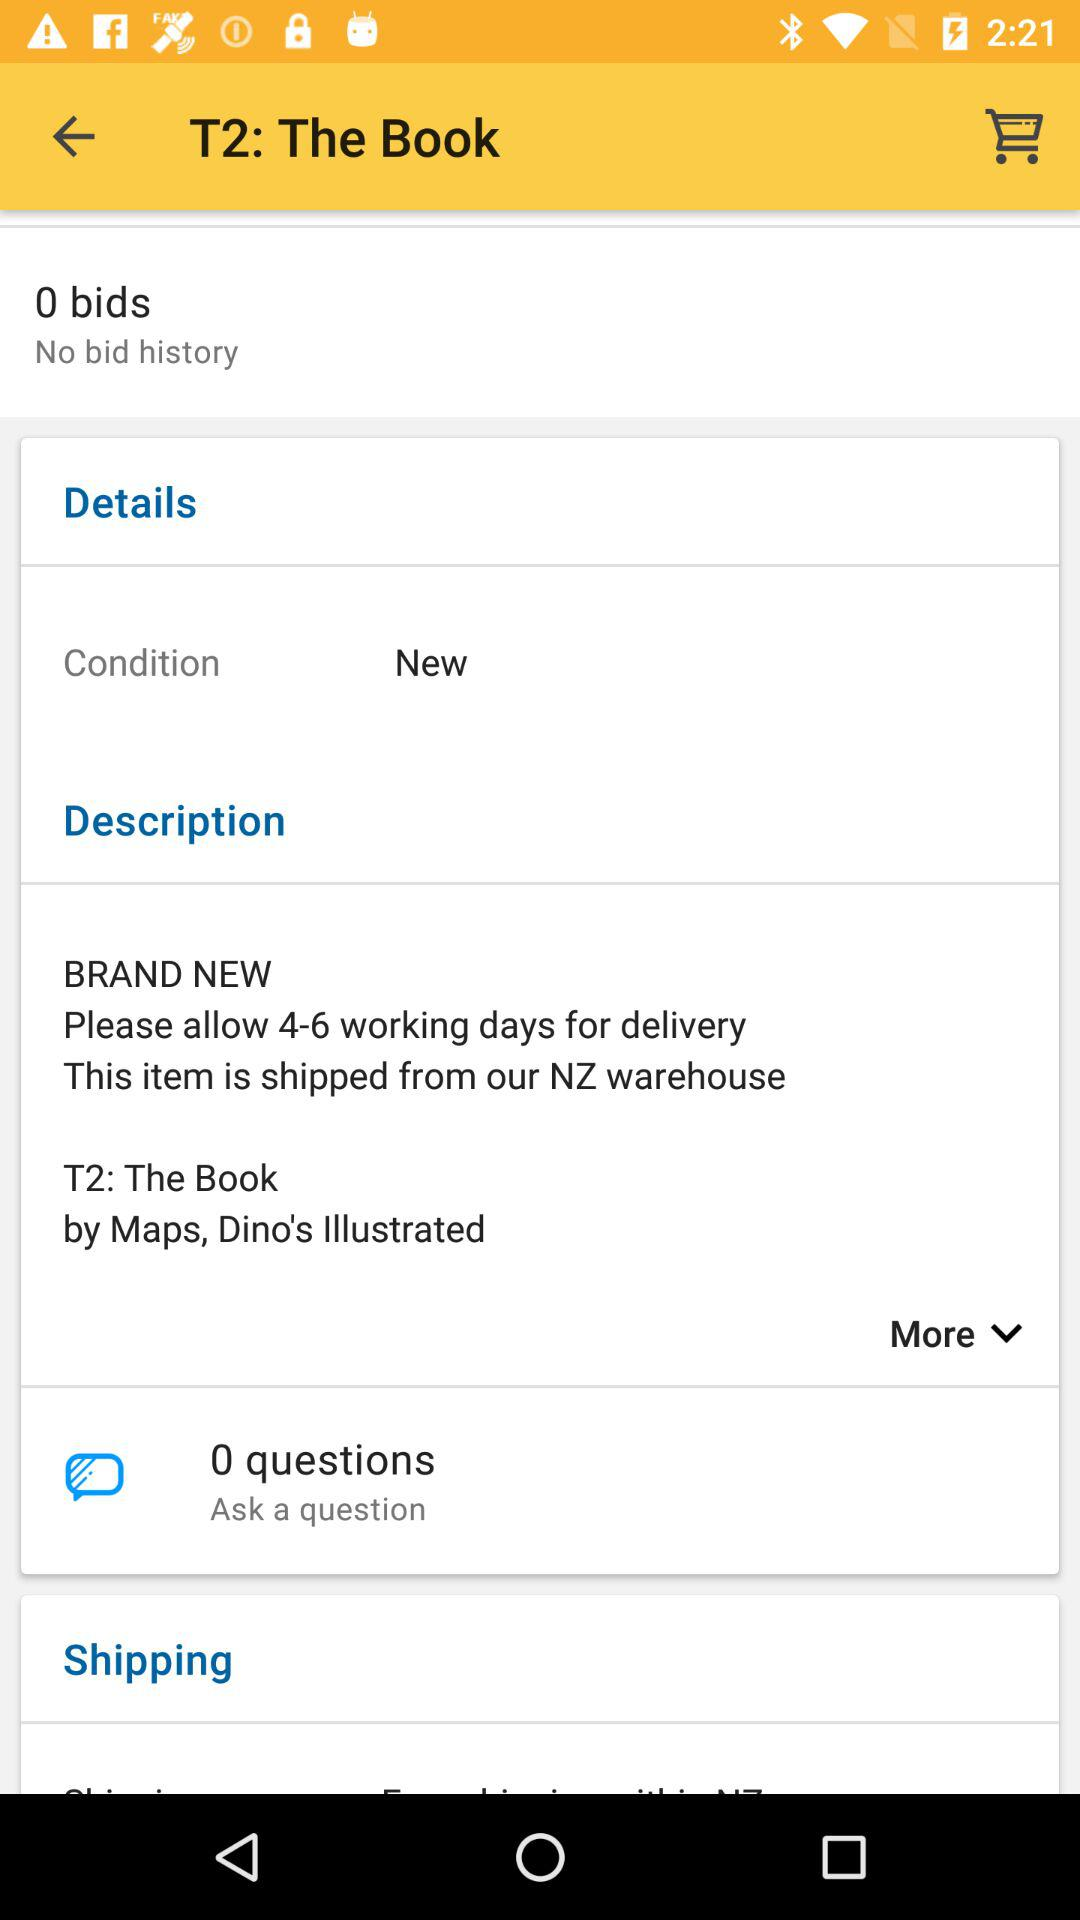What is the title of the book and who is the illustrator? The title of the book is 'T2: The Book' and it is illustrated by someone named Dino, as per the description 'by Maps, Dino's Illustrated'. 